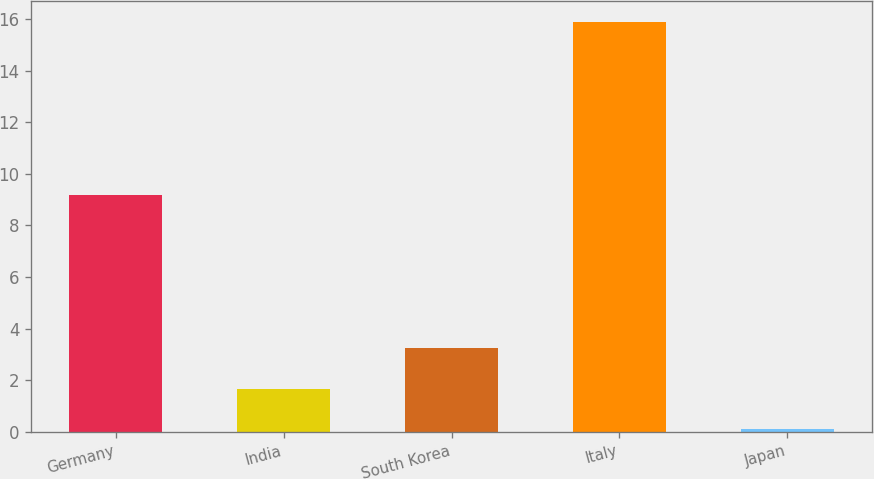<chart> <loc_0><loc_0><loc_500><loc_500><bar_chart><fcel>Germany<fcel>India<fcel>South Korea<fcel>Italy<fcel>Japan<nl><fcel>9.2<fcel>1.68<fcel>3.26<fcel>15.9<fcel>0.1<nl></chart> 